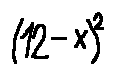Convert formula to latex. <formula><loc_0><loc_0><loc_500><loc_500>( 1 2 - x ) ^ { 2 }</formula> 